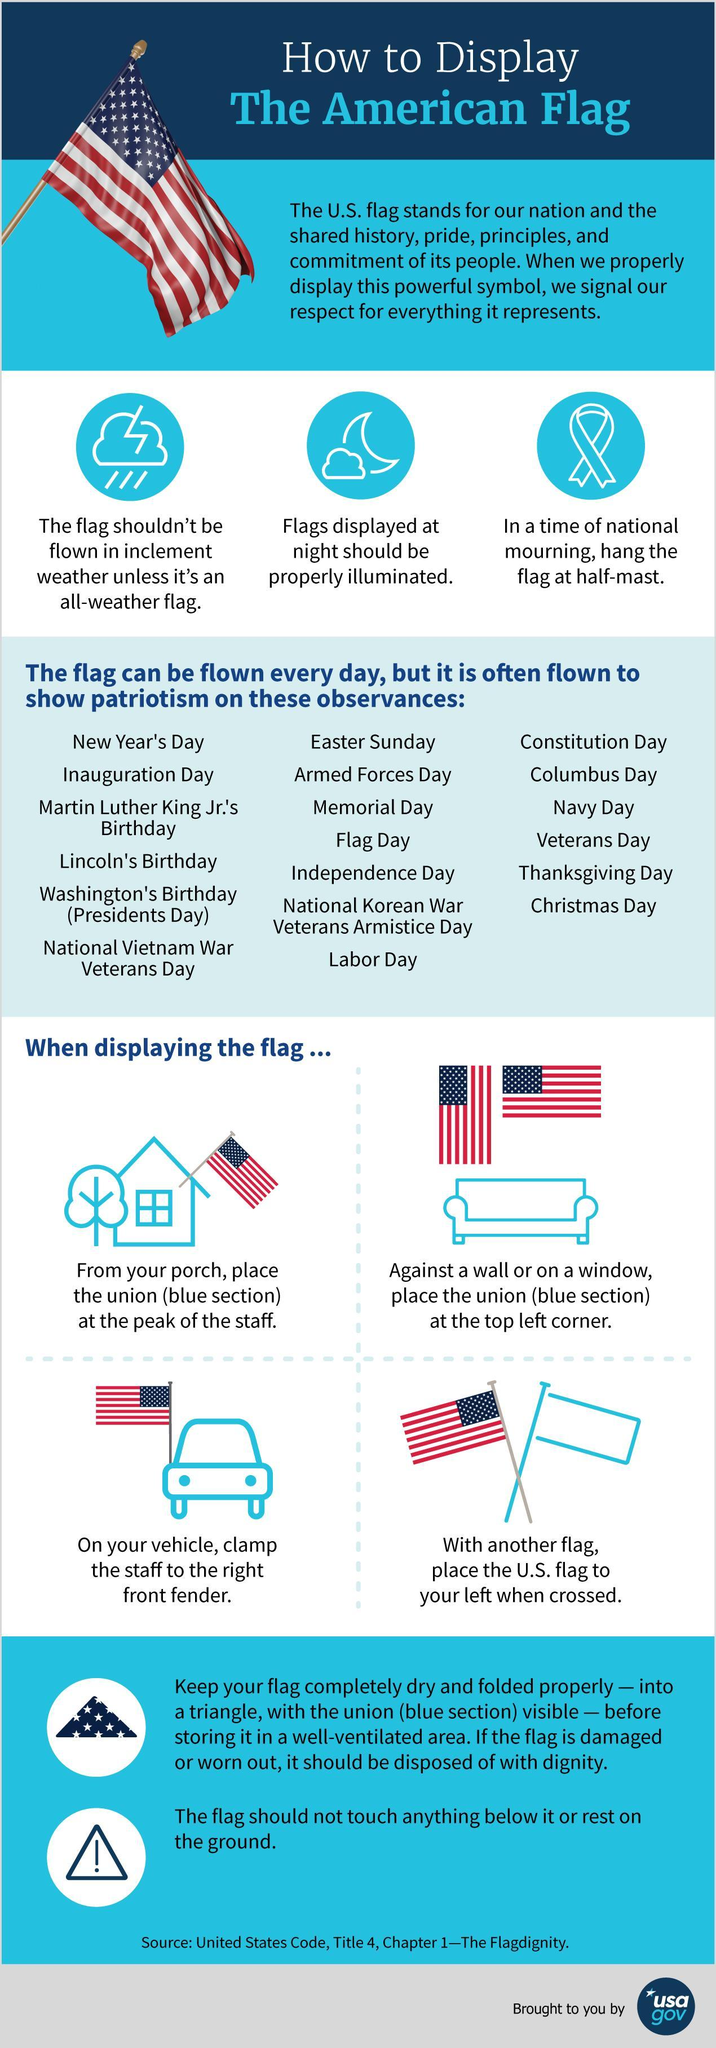how should it be if the flag is displayed at night
Answer the question with a short phrase. properly illuminated Other than blue and white, what is the other colour in the American Flag, red or green? red what is prohibited the flag should not touch anything below it or rest on the ground With another flag, how should the US flag be placed to your left when crossed how should the flag be displayed against a wall or on a window place the union (blue section) at the top left corner How many observances is the flag often flown to show patriotism 19 When should be the flag at half-mast in a time of national mourning 